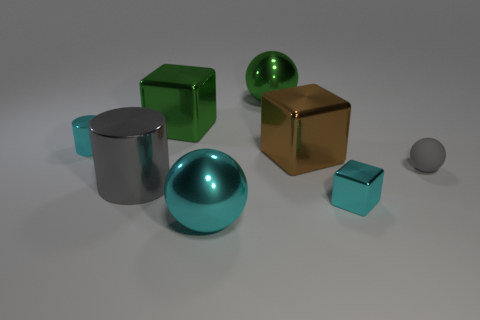Is there anything else that has the same material as the gray sphere?
Ensure brevity in your answer.  No. There is a brown block to the right of the green object that is on the right side of the big green metallic block; how big is it?
Offer a terse response. Large. What shape is the gray shiny object?
Make the answer very short. Cylinder. What is the ball right of the brown metal object made of?
Keep it short and to the point. Rubber. There is a cube that is left of the large sphere that is in front of the cyan thing behind the gray sphere; what is its color?
Ensure brevity in your answer.  Green. There is a cylinder that is the same size as the brown metallic thing; what is its color?
Give a very brief answer. Gray. How many shiny things are either brown objects or large blocks?
Ensure brevity in your answer.  2. The large cylinder that is made of the same material as the large cyan sphere is what color?
Offer a very short reply. Gray. The big gray thing left of the cube that is behind the big brown metal block is made of what material?
Offer a terse response. Metal. How many objects are either metal blocks in front of the small cyan cylinder or tiny metal things right of the small cyan shiny cylinder?
Make the answer very short. 2. 